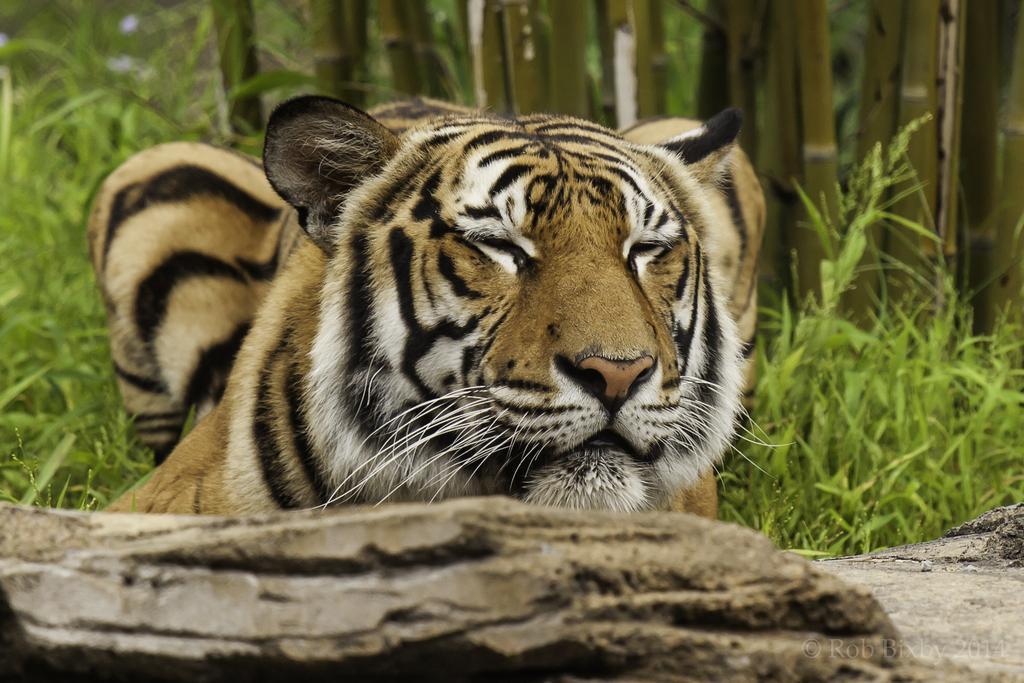Could you give a brief overview of what you see in this image? In this picture we can see a tiger in the front, there are some bamboo sticks and grass in the background, it looks like a rock at the bottom. 